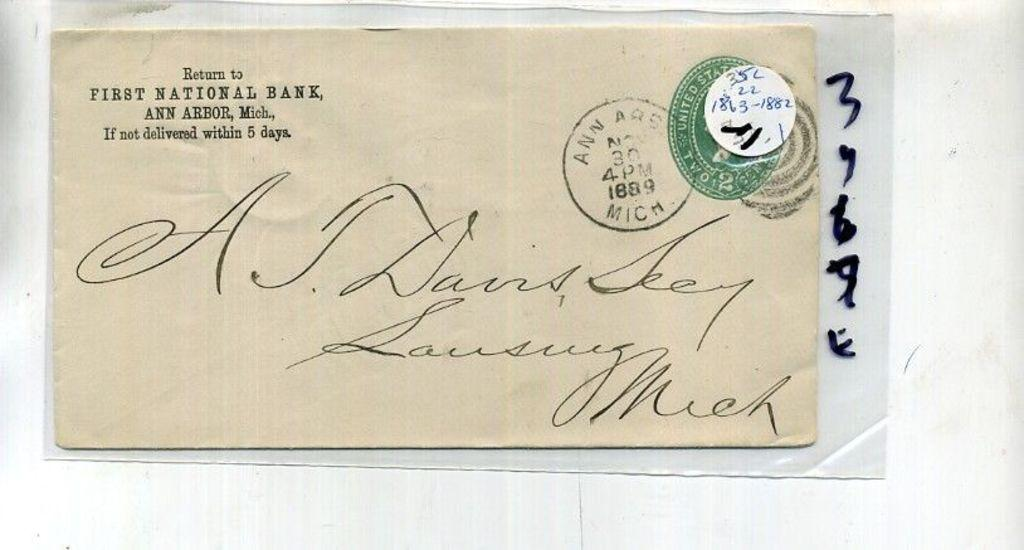Provide a one-sentence caption for the provided image. An envelope with a return address they says First National Bank and is addressed to A.J. Dains Seey. 